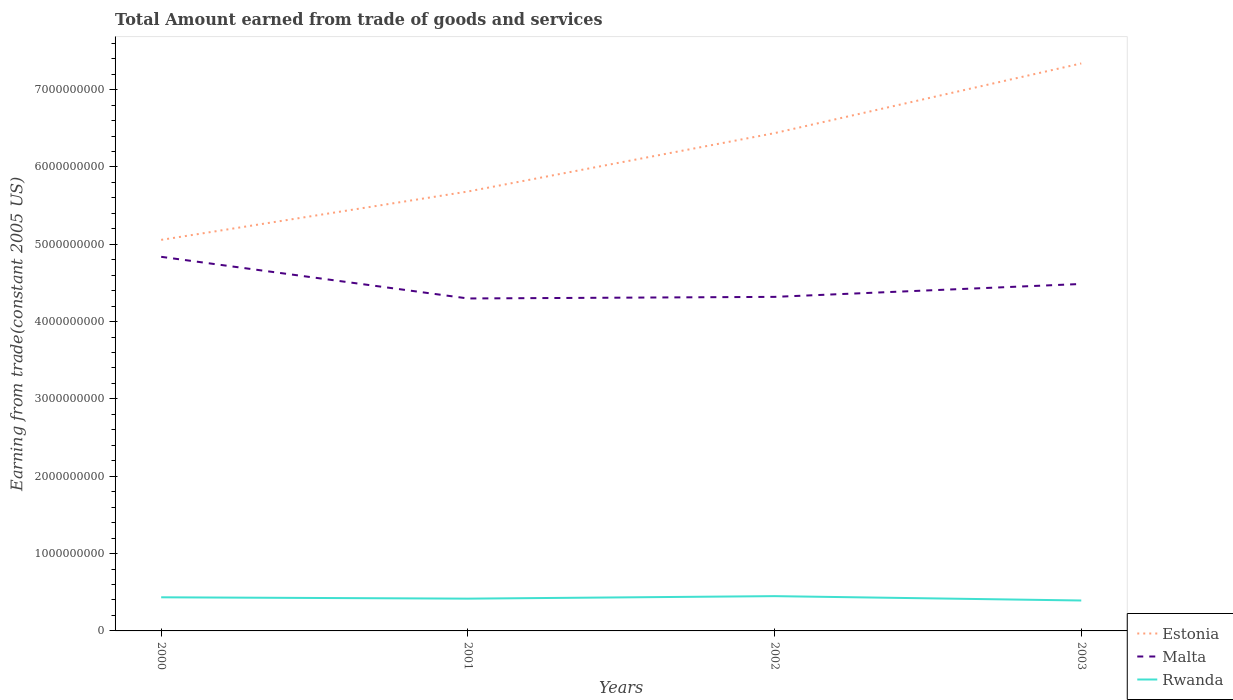Does the line corresponding to Rwanda intersect with the line corresponding to Estonia?
Offer a very short reply. No. Across all years, what is the maximum total amount earned by trading goods and services in Estonia?
Keep it short and to the point. 5.06e+09. In which year was the total amount earned by trading goods and services in Malta maximum?
Give a very brief answer. 2001. What is the total total amount earned by trading goods and services in Estonia in the graph?
Keep it short and to the point. -9.01e+08. What is the difference between the highest and the second highest total amount earned by trading goods and services in Malta?
Keep it short and to the point. 5.39e+08. Is the total amount earned by trading goods and services in Rwanda strictly greater than the total amount earned by trading goods and services in Estonia over the years?
Offer a very short reply. Yes. How many lines are there?
Provide a succinct answer. 3. What is the difference between two consecutive major ticks on the Y-axis?
Provide a short and direct response. 1.00e+09. Does the graph contain grids?
Provide a short and direct response. No. Where does the legend appear in the graph?
Offer a very short reply. Bottom right. How many legend labels are there?
Provide a short and direct response. 3. How are the legend labels stacked?
Your response must be concise. Vertical. What is the title of the graph?
Offer a very short reply. Total Amount earned from trade of goods and services. What is the label or title of the Y-axis?
Your response must be concise. Earning from trade(constant 2005 US). What is the Earning from trade(constant 2005 US) of Estonia in 2000?
Your response must be concise. 5.06e+09. What is the Earning from trade(constant 2005 US) of Malta in 2000?
Provide a short and direct response. 4.84e+09. What is the Earning from trade(constant 2005 US) of Rwanda in 2000?
Ensure brevity in your answer.  4.35e+08. What is the Earning from trade(constant 2005 US) in Estonia in 2001?
Offer a terse response. 5.68e+09. What is the Earning from trade(constant 2005 US) in Malta in 2001?
Your response must be concise. 4.30e+09. What is the Earning from trade(constant 2005 US) of Rwanda in 2001?
Ensure brevity in your answer.  4.17e+08. What is the Earning from trade(constant 2005 US) of Estonia in 2002?
Offer a terse response. 6.44e+09. What is the Earning from trade(constant 2005 US) of Malta in 2002?
Ensure brevity in your answer.  4.32e+09. What is the Earning from trade(constant 2005 US) in Rwanda in 2002?
Give a very brief answer. 4.50e+08. What is the Earning from trade(constant 2005 US) of Estonia in 2003?
Your answer should be compact. 7.34e+09. What is the Earning from trade(constant 2005 US) in Malta in 2003?
Make the answer very short. 4.49e+09. What is the Earning from trade(constant 2005 US) in Rwanda in 2003?
Offer a very short reply. 3.93e+08. Across all years, what is the maximum Earning from trade(constant 2005 US) in Estonia?
Provide a succinct answer. 7.34e+09. Across all years, what is the maximum Earning from trade(constant 2005 US) in Malta?
Your answer should be very brief. 4.84e+09. Across all years, what is the maximum Earning from trade(constant 2005 US) in Rwanda?
Give a very brief answer. 4.50e+08. Across all years, what is the minimum Earning from trade(constant 2005 US) of Estonia?
Make the answer very short. 5.06e+09. Across all years, what is the minimum Earning from trade(constant 2005 US) in Malta?
Your answer should be very brief. 4.30e+09. Across all years, what is the minimum Earning from trade(constant 2005 US) of Rwanda?
Keep it short and to the point. 3.93e+08. What is the total Earning from trade(constant 2005 US) of Estonia in the graph?
Your answer should be compact. 2.45e+1. What is the total Earning from trade(constant 2005 US) in Malta in the graph?
Provide a short and direct response. 1.79e+1. What is the total Earning from trade(constant 2005 US) in Rwanda in the graph?
Give a very brief answer. 1.70e+09. What is the difference between the Earning from trade(constant 2005 US) of Estonia in 2000 and that in 2001?
Give a very brief answer. -6.25e+08. What is the difference between the Earning from trade(constant 2005 US) in Malta in 2000 and that in 2001?
Offer a very short reply. 5.39e+08. What is the difference between the Earning from trade(constant 2005 US) in Rwanda in 2000 and that in 2001?
Offer a very short reply. 1.73e+07. What is the difference between the Earning from trade(constant 2005 US) in Estonia in 2000 and that in 2002?
Offer a terse response. -1.38e+09. What is the difference between the Earning from trade(constant 2005 US) in Malta in 2000 and that in 2002?
Give a very brief answer. 5.18e+08. What is the difference between the Earning from trade(constant 2005 US) in Rwanda in 2000 and that in 2002?
Provide a succinct answer. -1.50e+07. What is the difference between the Earning from trade(constant 2005 US) of Estonia in 2000 and that in 2003?
Give a very brief answer. -2.28e+09. What is the difference between the Earning from trade(constant 2005 US) in Malta in 2000 and that in 2003?
Give a very brief answer. 3.51e+08. What is the difference between the Earning from trade(constant 2005 US) in Rwanda in 2000 and that in 2003?
Keep it short and to the point. 4.14e+07. What is the difference between the Earning from trade(constant 2005 US) of Estonia in 2001 and that in 2002?
Provide a succinct answer. -7.55e+08. What is the difference between the Earning from trade(constant 2005 US) of Malta in 2001 and that in 2002?
Provide a succinct answer. -2.06e+07. What is the difference between the Earning from trade(constant 2005 US) of Rwanda in 2001 and that in 2002?
Your answer should be very brief. -3.23e+07. What is the difference between the Earning from trade(constant 2005 US) in Estonia in 2001 and that in 2003?
Offer a very short reply. -1.66e+09. What is the difference between the Earning from trade(constant 2005 US) in Malta in 2001 and that in 2003?
Your response must be concise. -1.87e+08. What is the difference between the Earning from trade(constant 2005 US) in Rwanda in 2001 and that in 2003?
Make the answer very short. 2.41e+07. What is the difference between the Earning from trade(constant 2005 US) of Estonia in 2002 and that in 2003?
Your response must be concise. -9.01e+08. What is the difference between the Earning from trade(constant 2005 US) in Malta in 2002 and that in 2003?
Give a very brief answer. -1.67e+08. What is the difference between the Earning from trade(constant 2005 US) of Rwanda in 2002 and that in 2003?
Provide a short and direct response. 5.64e+07. What is the difference between the Earning from trade(constant 2005 US) of Estonia in 2000 and the Earning from trade(constant 2005 US) of Malta in 2001?
Provide a succinct answer. 7.58e+08. What is the difference between the Earning from trade(constant 2005 US) in Estonia in 2000 and the Earning from trade(constant 2005 US) in Rwanda in 2001?
Offer a very short reply. 4.64e+09. What is the difference between the Earning from trade(constant 2005 US) of Malta in 2000 and the Earning from trade(constant 2005 US) of Rwanda in 2001?
Ensure brevity in your answer.  4.42e+09. What is the difference between the Earning from trade(constant 2005 US) of Estonia in 2000 and the Earning from trade(constant 2005 US) of Malta in 2002?
Give a very brief answer. 7.37e+08. What is the difference between the Earning from trade(constant 2005 US) in Estonia in 2000 and the Earning from trade(constant 2005 US) in Rwanda in 2002?
Your answer should be very brief. 4.61e+09. What is the difference between the Earning from trade(constant 2005 US) in Malta in 2000 and the Earning from trade(constant 2005 US) in Rwanda in 2002?
Provide a short and direct response. 4.39e+09. What is the difference between the Earning from trade(constant 2005 US) in Estonia in 2000 and the Earning from trade(constant 2005 US) in Malta in 2003?
Ensure brevity in your answer.  5.70e+08. What is the difference between the Earning from trade(constant 2005 US) in Estonia in 2000 and the Earning from trade(constant 2005 US) in Rwanda in 2003?
Offer a terse response. 4.66e+09. What is the difference between the Earning from trade(constant 2005 US) in Malta in 2000 and the Earning from trade(constant 2005 US) in Rwanda in 2003?
Your answer should be compact. 4.44e+09. What is the difference between the Earning from trade(constant 2005 US) of Estonia in 2001 and the Earning from trade(constant 2005 US) of Malta in 2002?
Your answer should be compact. 1.36e+09. What is the difference between the Earning from trade(constant 2005 US) in Estonia in 2001 and the Earning from trade(constant 2005 US) in Rwanda in 2002?
Ensure brevity in your answer.  5.23e+09. What is the difference between the Earning from trade(constant 2005 US) of Malta in 2001 and the Earning from trade(constant 2005 US) of Rwanda in 2002?
Give a very brief answer. 3.85e+09. What is the difference between the Earning from trade(constant 2005 US) in Estonia in 2001 and the Earning from trade(constant 2005 US) in Malta in 2003?
Your answer should be compact. 1.20e+09. What is the difference between the Earning from trade(constant 2005 US) in Estonia in 2001 and the Earning from trade(constant 2005 US) in Rwanda in 2003?
Offer a terse response. 5.29e+09. What is the difference between the Earning from trade(constant 2005 US) in Malta in 2001 and the Earning from trade(constant 2005 US) in Rwanda in 2003?
Provide a short and direct response. 3.91e+09. What is the difference between the Earning from trade(constant 2005 US) in Estonia in 2002 and the Earning from trade(constant 2005 US) in Malta in 2003?
Make the answer very short. 1.95e+09. What is the difference between the Earning from trade(constant 2005 US) of Estonia in 2002 and the Earning from trade(constant 2005 US) of Rwanda in 2003?
Your answer should be compact. 6.04e+09. What is the difference between the Earning from trade(constant 2005 US) in Malta in 2002 and the Earning from trade(constant 2005 US) in Rwanda in 2003?
Provide a succinct answer. 3.93e+09. What is the average Earning from trade(constant 2005 US) of Estonia per year?
Offer a very short reply. 6.13e+09. What is the average Earning from trade(constant 2005 US) in Malta per year?
Offer a terse response. 4.49e+09. What is the average Earning from trade(constant 2005 US) of Rwanda per year?
Provide a short and direct response. 4.24e+08. In the year 2000, what is the difference between the Earning from trade(constant 2005 US) in Estonia and Earning from trade(constant 2005 US) in Malta?
Make the answer very short. 2.19e+08. In the year 2000, what is the difference between the Earning from trade(constant 2005 US) in Estonia and Earning from trade(constant 2005 US) in Rwanda?
Give a very brief answer. 4.62e+09. In the year 2000, what is the difference between the Earning from trade(constant 2005 US) in Malta and Earning from trade(constant 2005 US) in Rwanda?
Your answer should be very brief. 4.40e+09. In the year 2001, what is the difference between the Earning from trade(constant 2005 US) of Estonia and Earning from trade(constant 2005 US) of Malta?
Give a very brief answer. 1.38e+09. In the year 2001, what is the difference between the Earning from trade(constant 2005 US) of Estonia and Earning from trade(constant 2005 US) of Rwanda?
Make the answer very short. 5.26e+09. In the year 2001, what is the difference between the Earning from trade(constant 2005 US) of Malta and Earning from trade(constant 2005 US) of Rwanda?
Keep it short and to the point. 3.88e+09. In the year 2002, what is the difference between the Earning from trade(constant 2005 US) in Estonia and Earning from trade(constant 2005 US) in Malta?
Ensure brevity in your answer.  2.12e+09. In the year 2002, what is the difference between the Earning from trade(constant 2005 US) of Estonia and Earning from trade(constant 2005 US) of Rwanda?
Provide a succinct answer. 5.99e+09. In the year 2002, what is the difference between the Earning from trade(constant 2005 US) of Malta and Earning from trade(constant 2005 US) of Rwanda?
Your response must be concise. 3.87e+09. In the year 2003, what is the difference between the Earning from trade(constant 2005 US) of Estonia and Earning from trade(constant 2005 US) of Malta?
Keep it short and to the point. 2.85e+09. In the year 2003, what is the difference between the Earning from trade(constant 2005 US) of Estonia and Earning from trade(constant 2005 US) of Rwanda?
Provide a short and direct response. 6.95e+09. In the year 2003, what is the difference between the Earning from trade(constant 2005 US) in Malta and Earning from trade(constant 2005 US) in Rwanda?
Offer a terse response. 4.09e+09. What is the ratio of the Earning from trade(constant 2005 US) of Estonia in 2000 to that in 2001?
Make the answer very short. 0.89. What is the ratio of the Earning from trade(constant 2005 US) of Malta in 2000 to that in 2001?
Ensure brevity in your answer.  1.13. What is the ratio of the Earning from trade(constant 2005 US) of Rwanda in 2000 to that in 2001?
Offer a terse response. 1.04. What is the ratio of the Earning from trade(constant 2005 US) in Estonia in 2000 to that in 2002?
Offer a terse response. 0.79. What is the ratio of the Earning from trade(constant 2005 US) of Malta in 2000 to that in 2002?
Offer a terse response. 1.12. What is the ratio of the Earning from trade(constant 2005 US) in Rwanda in 2000 to that in 2002?
Your response must be concise. 0.97. What is the ratio of the Earning from trade(constant 2005 US) of Estonia in 2000 to that in 2003?
Offer a terse response. 0.69. What is the ratio of the Earning from trade(constant 2005 US) of Malta in 2000 to that in 2003?
Provide a short and direct response. 1.08. What is the ratio of the Earning from trade(constant 2005 US) of Rwanda in 2000 to that in 2003?
Give a very brief answer. 1.11. What is the ratio of the Earning from trade(constant 2005 US) of Estonia in 2001 to that in 2002?
Keep it short and to the point. 0.88. What is the ratio of the Earning from trade(constant 2005 US) of Rwanda in 2001 to that in 2002?
Give a very brief answer. 0.93. What is the ratio of the Earning from trade(constant 2005 US) of Estonia in 2001 to that in 2003?
Keep it short and to the point. 0.77. What is the ratio of the Earning from trade(constant 2005 US) in Malta in 2001 to that in 2003?
Give a very brief answer. 0.96. What is the ratio of the Earning from trade(constant 2005 US) in Rwanda in 2001 to that in 2003?
Provide a succinct answer. 1.06. What is the ratio of the Earning from trade(constant 2005 US) of Estonia in 2002 to that in 2003?
Give a very brief answer. 0.88. What is the ratio of the Earning from trade(constant 2005 US) of Malta in 2002 to that in 2003?
Ensure brevity in your answer.  0.96. What is the ratio of the Earning from trade(constant 2005 US) of Rwanda in 2002 to that in 2003?
Offer a terse response. 1.14. What is the difference between the highest and the second highest Earning from trade(constant 2005 US) in Estonia?
Provide a short and direct response. 9.01e+08. What is the difference between the highest and the second highest Earning from trade(constant 2005 US) of Malta?
Your answer should be very brief. 3.51e+08. What is the difference between the highest and the second highest Earning from trade(constant 2005 US) in Rwanda?
Provide a short and direct response. 1.50e+07. What is the difference between the highest and the lowest Earning from trade(constant 2005 US) of Estonia?
Offer a terse response. 2.28e+09. What is the difference between the highest and the lowest Earning from trade(constant 2005 US) of Malta?
Make the answer very short. 5.39e+08. What is the difference between the highest and the lowest Earning from trade(constant 2005 US) in Rwanda?
Your response must be concise. 5.64e+07. 